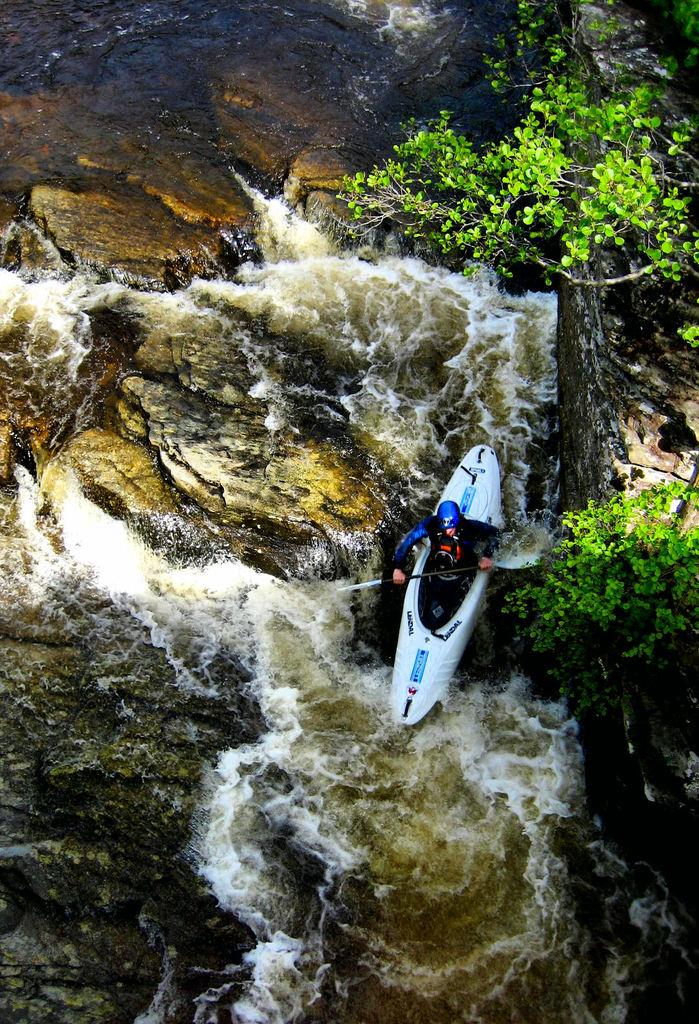Who is in the image? There is a person in the image. What is the person doing in the image? The person is on a boat and holding a paddle. What is the person wearing in the image? The person is wearing a blue dress and a helmet. Where is the boat located in the image? The boat is on the water. What else can be seen in the image? There is a tree visible in the image. What type of net is being used to catch fish in the image? There is no net present in the image, and no fishing activity is depicted. 